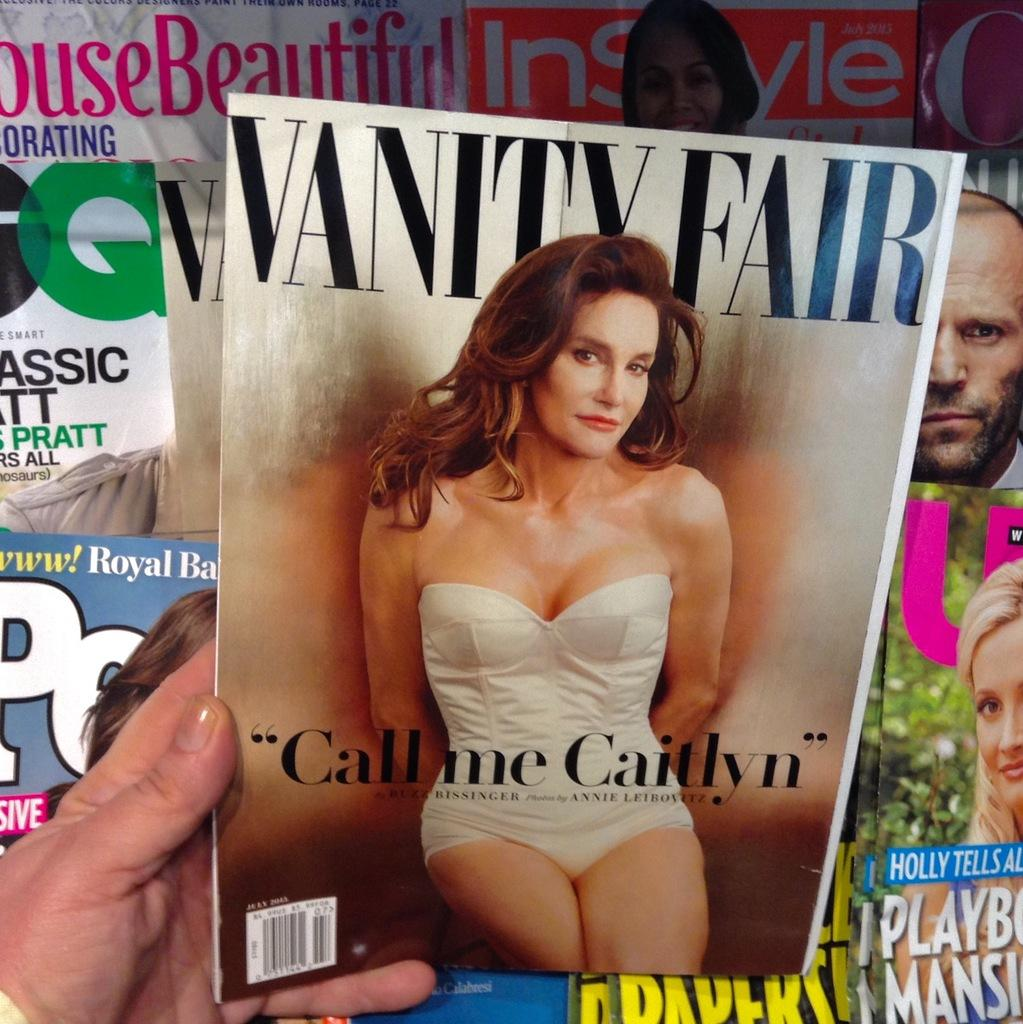What type of plates are shown in the image? There are palm-plates in the image. Can you describe any body parts visible in the image? A person's hand is visible in the image. What is the person holding in the image? There is a paper being held in the image. What type of tooth is visible in the image? There is no tooth visible in the image. 